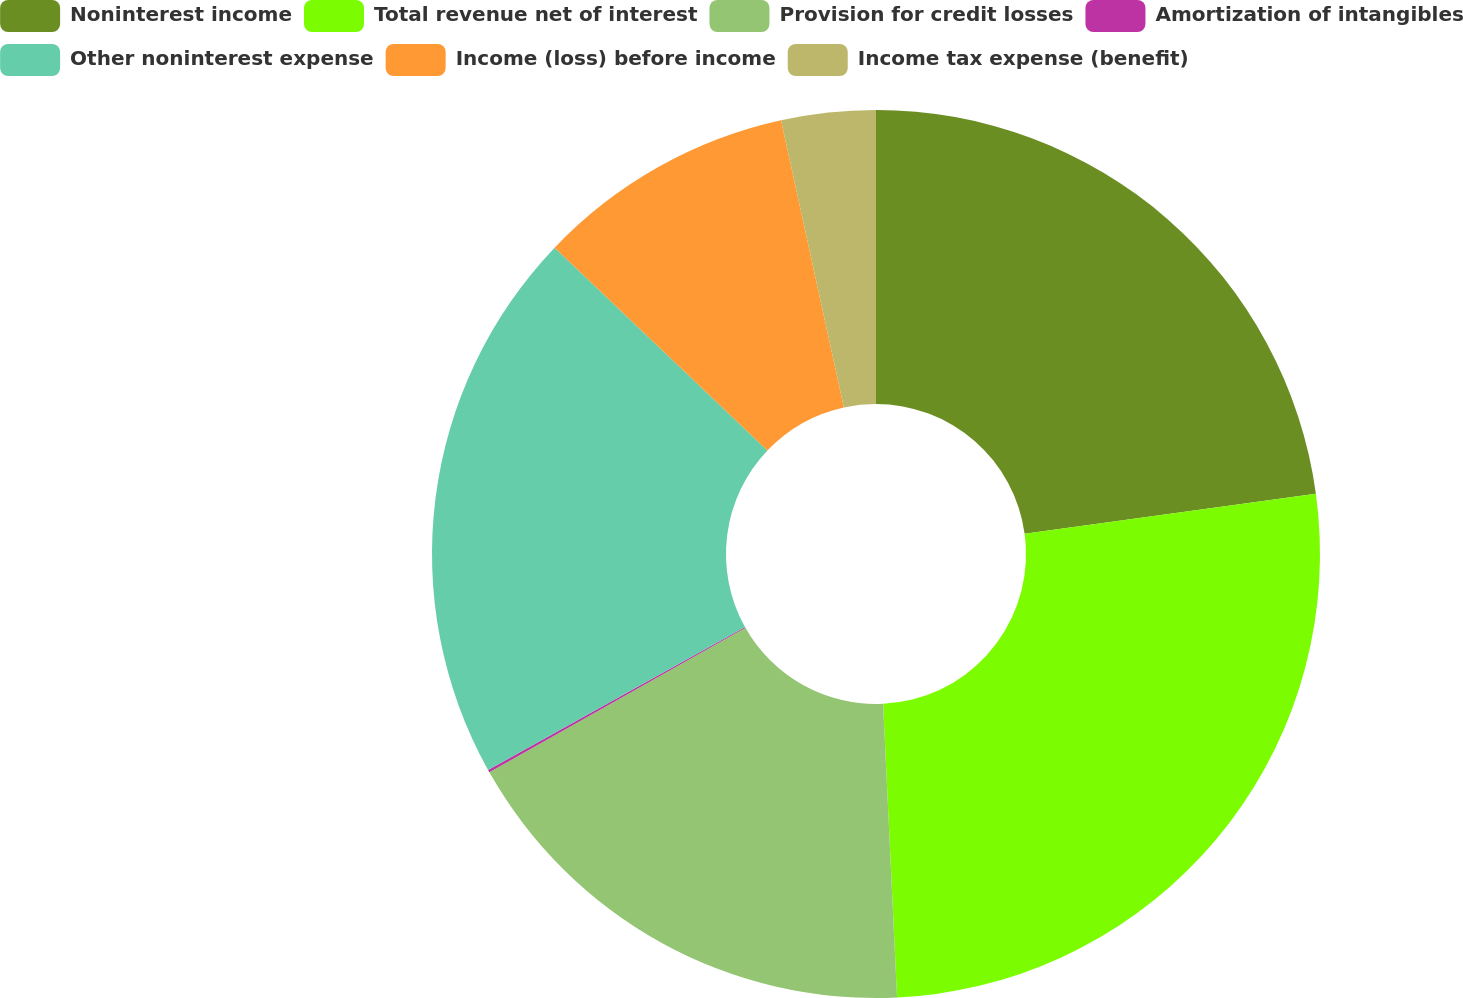Convert chart. <chart><loc_0><loc_0><loc_500><loc_500><pie_chart><fcel>Noninterest income<fcel>Total revenue net of interest<fcel>Provision for credit losses<fcel>Amortization of intangibles<fcel>Other noninterest expense<fcel>Income (loss) before income<fcel>Income tax expense (benefit)<nl><fcel>22.83%<fcel>26.41%<fcel>17.57%<fcel>0.1%<fcel>20.2%<fcel>9.45%<fcel>3.43%<nl></chart> 